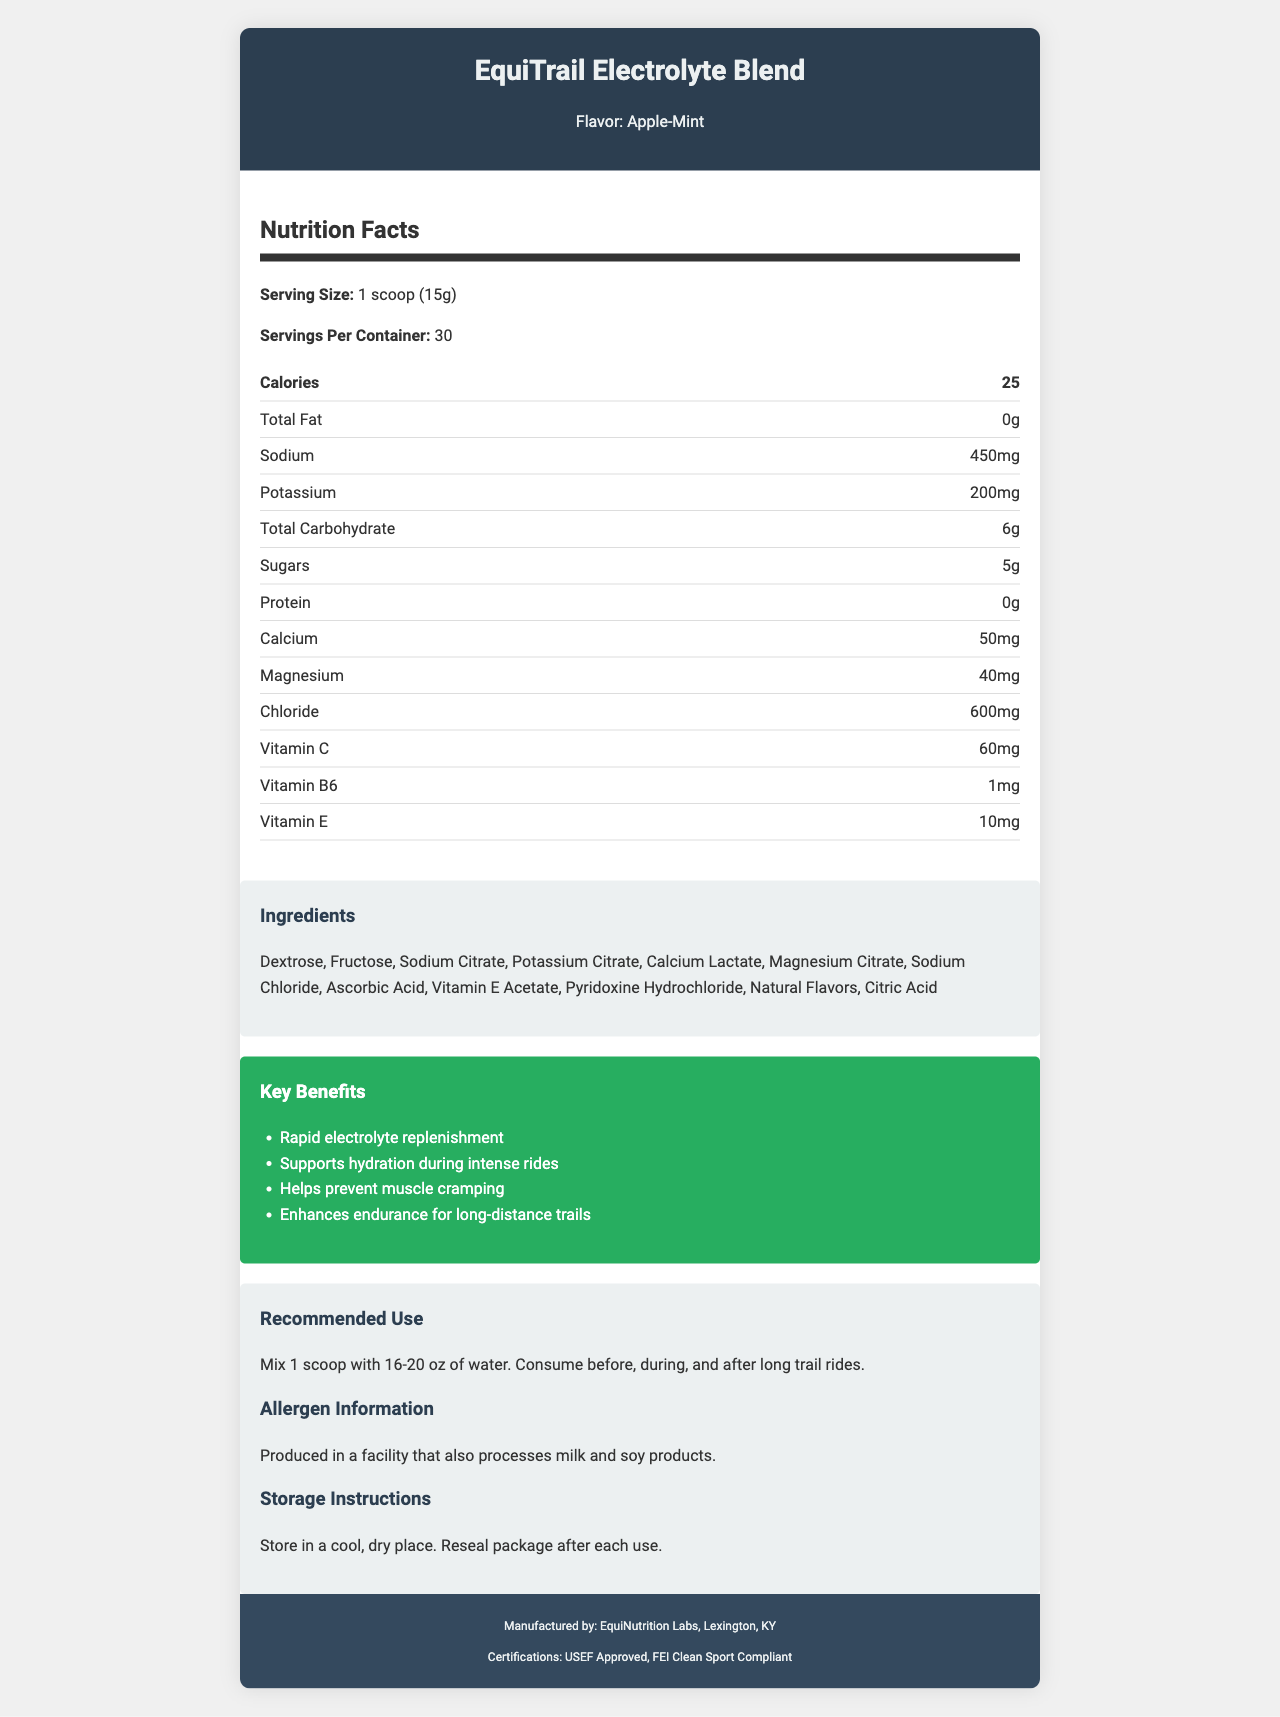what is the serving size of EquiTrail Electrolyte Blend? The serving size is listed under the "Nutrition Facts" section as "1 scoop (15g)".
Answer: 1 scoop (15g) how many servings are there per container? The number of servings per container is specified in the "Nutrition Facts" section as "30".
Answer: 30 how many calories are in one serving of EquiTrail Electrolyte Blend? The calorie content per serving is stated as "25" in the "Nutrition Facts" section.
Answer: 25 how much sodium is in each serving? The amount of sodium per serving is given as "450mg" in the "Nutrition Facts" section.
Answer: 450mg which dominant ingredient in EquiTrail Electrolyte Blend is listed first? The ingredients are listed in order, with Dextrose being the first ingredient in the "Ingredients" list.
Answer: Dextrose what flavor is the EquiTrail Electrolyte Blend? The flavor is mentioned at the top of the document as "Apple-Mint".
Answer: Apple-Mint which vitamin is present in the highest amount per serving in EquiTrail Electrolyte Blend? Vitamin C is listed with a value of 60mg, which is higher than the amounts of Vitamin B6 and Vitamin E, listed as 1mg and 10mg respectively.
Answer: Vitamin C what is the total carbohydrate content per serving? The amount of total carbohydrate per serving is listed as "6g" in the "Nutrition Facts" section.
Answer: 6g how should EquiTrail Electrolyte Blend be consumed? The recommended use is detailed in the "Recommended Use" section, specifying to mix 1 scoop with 16-20 oz of water and to consume it before, during, and after long trail rides.
Answer: Mix 1 scoop with 16-20 oz of water. Consume before, during, and after long trail rides. what are the key benefits of using EquiTrail Electrolyte Blend? The key benefits are listed in the "Key Benefits" section, which includes rapid electrolyte replenishment, supporting hydration, preventing muscle cramping, and enhancing endurance.
Answer: (1) Rapid electrolyte replenishment, (2) Supports hydration during intense rides, (3) Helps prevent muscle cramping, (4) Enhances endurance for long-distance trails which of the following certifications does the product have? A. USDA Organic B. Non-GMO C. USEF Approved In the "Certifications" section, the product has "USEF Approved" and "FEI Clean Sport Compliant" certifications, but not USDA Organic or Non-GMO.
Answer: C. USEF Approved the storage instructions for the product recommend which of the following actions? A. Store in a warm place B. Keep refrigerated C. Store in a cool, dry place The "Storage Instructions" are to store in a cool, dry place and to reseal the package after each use.
Answer: C. Store in a cool, dry place is EquiTrail Electrolyte Blend produced in a facility that processes milk and soy products? The allergen information specifies that it is produced in a facility that also processes milk and soy products.
Answer: Yes does EquiTrail Electrolyte Blend contain protein? The "Nutrition Facts" section lists the protein content as 0g, indicating it does not contain protein.
Answer: No summarize the main details of the EquiTrail Electrolyte Blend nutrition label. The document includes detailed information about the product, including nutrition facts, ingredients, benefits, usage recommendations, storage instructions, allergens, and certifications.
Answer: The EquiTrail Electrolyte Blend is a specialized electrolyte drink mix for long trail rides, offering rapid electrolyte replenishment. Each serving is 15g, providing 25 calories, 450mg sodium, 200mg potassium, and other essential minerals and vitamins. The blend contains natural ingredients like Dextrose and Fructose, and comes in an Apple-Mint flavor. It supports hydration, muscle cramp prevention, and endurance. Produced in a facility that processes milk and soy, it should be stored in a cool, dry place. Manufactured by EquiNutrition Labs, it is certified by USEF and FEI. how much sugar does EquiTrail Electrolyte Blend contain per serving? It is clearly listed in the "Nutrition Facts" section that each serving contains 5g of sugars.
Answer: 5g where is EquiTrail Electrolyte Blend manufactured? The manufacturer information at the bottom of the document states that it is produced by EquiNutrition Labs located in Lexington, KY.
Answer: Lexington, KY does this document provide the price of EquiTrail Electrolyte Blend? The document does not include any information regarding the price of the product.
Answer: Not enough information 